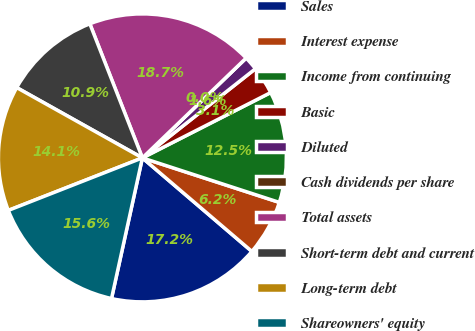<chart> <loc_0><loc_0><loc_500><loc_500><pie_chart><fcel>Sales<fcel>Interest expense<fcel>Income from continuing<fcel>Basic<fcel>Diluted<fcel>Cash dividends per share<fcel>Total assets<fcel>Short-term debt and current<fcel>Long-term debt<fcel>Shareowners' equity<nl><fcel>17.19%<fcel>6.25%<fcel>12.5%<fcel>3.13%<fcel>1.57%<fcel>0.0%<fcel>18.75%<fcel>10.94%<fcel>14.06%<fcel>15.62%<nl></chart> 